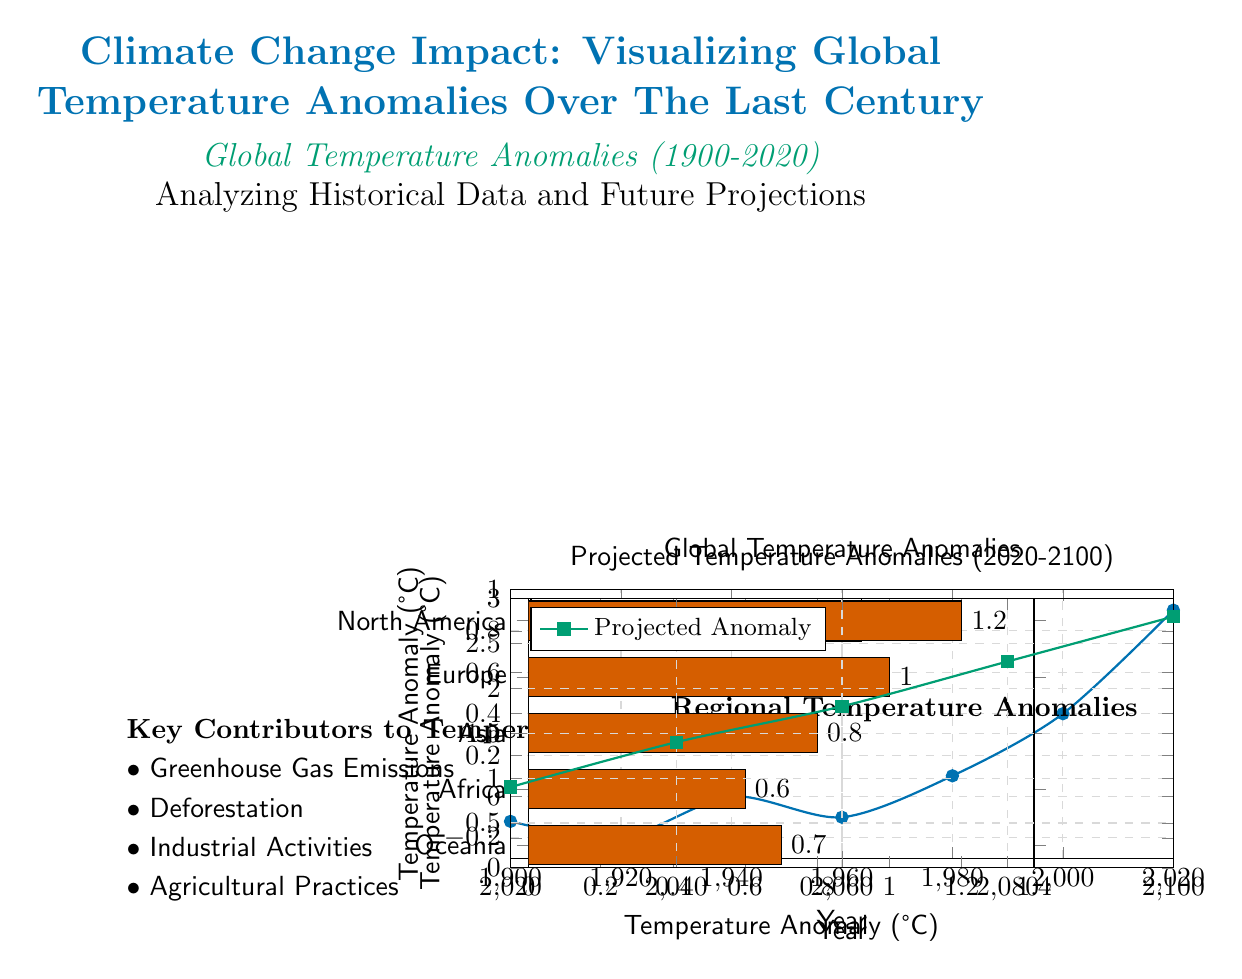What was the temperature anomaly in the year 2000? According to the temperature data plotted on the graph, the anomaly for the year 2000 is located at the point marked on the line representing temperature anomalies. It shows a value of 0.4 degrees Celsius.
Answer: 0.4 In which region is the highest temperature anomaly recorded? By examining the regional temperature anomalies bar chart on the right side of the diagram, North America is shown to have the highest temperature anomaly, represented by a value of 1.2 degrees Celsius.
Answer: North America What is the temperature anomaly for Asia? The bar chart depicting regional temperature anomalies indicates that Asia has a temperature anomaly of 0.8 degrees Celsius. This can be read directly from the bar corresponding to Asia in the chart.
Answer: 0.8 When is the projected temperature anomaly expected to reach 2.3 degrees Celsius? The projections are shown on a separate line graph, which indicates the predicted temperature anomalies over time. Checking the coordinates on this graph shows that 2.3 degrees Celsius is projected for the year 2080.
Answer: 2080 How many key contributors to temperature anomalies are listed in the diagram? The left section of the diagram lists four key contributors to temperature anomalies, which include Greenhouse Gas Emissions, Deforestation, Industrial Activities, and Agricultural Practices. Counting these items gives the total.
Answer: 4 What was the temperature anomaly in 1960? The line graph shows that the temperature anomaly for the year 1960 is marked at a value of -0.1 degrees Celsius. This information can be directly derived from the respective point on the graph.
Answer: -0.1 What trend do the projected temperature anomalies show from 2020 to 2100? By analyzing the smooth line on the projected temperature anomalies graph, it’s evident that the trend indicates an increase in temperature anomalies over the years, rising from 0.9 degrees Celsius in 2020 to 2.8 degrees Celsius by 2100. The continuous upward slope of the line confirms this trend.
Answer: Increase What is the minimum recorded temperature anomaly in the diagram? Referring to the temperature data plotted from 1900 to 2020, the minimum recorded anomaly shown on the graph is -0.2 degrees Celsius in the year 1920. This can be spotted as the lowest point on the plotted line.
Answer: -0.2 